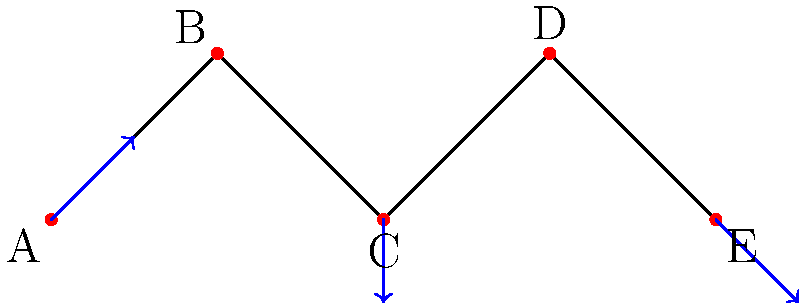In the force-directed graph layout shown above, which optimization technique would be most effective for reducing edge crossings and improving the overall layout quality, particularly for nodes B and D? To optimize node placement in a large force-directed graph layout and reduce edge crossings, we need to consider several factors:

1. Force-directed algorithms: These algorithms simulate a physical system where nodes repel each other, and edges act as springs. The goal is to minimize the energy of the system.

2. Edge crossings: In the given graph, there are no edge crossings, but the layout could be improved to distribute nodes more evenly.

3. Node distribution: Nodes B and D are positioned higher than the others, which may not be optimal for a balanced layout.

4. Local vs. global optimization: Local optimization techniques focus on improving the position of individual nodes, while global optimization considers the entire graph structure.

5. Multilevel techniques: For large graphs, multilevel approaches can be more effective. They work by coarsening the graph, optimizing the coarse graph, and then refining it.

6. Simulated annealing: This technique can help avoid local minima by occasionally accepting worse configurations to explore the solution space more thoroughly.

For nodes B and D specifically, we can apply a local optimization technique:

7. Adjust vertical positions: Lower the positions of nodes B and D slightly to create a more balanced layout.

8. Force adjustment: Increase the repulsive force between nodes B and D to push them apart horizontally.

Given the small size of this graph, a combination of local optimization and simulated annealing would be most effective. This approach would:

9. Improve the overall layout by allowing nodes to settle into a more balanced configuration.
10. Reduce the likelihood of getting stuck in local minima.
11. Address the specific issue with nodes B and D by giving them more freedom to move.

Therefore, the most effective technique for this scenario would be a combination of local optimization with simulated annealing.
Answer: Local optimization with simulated annealing 